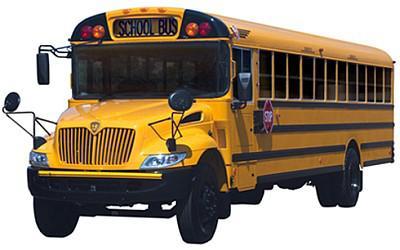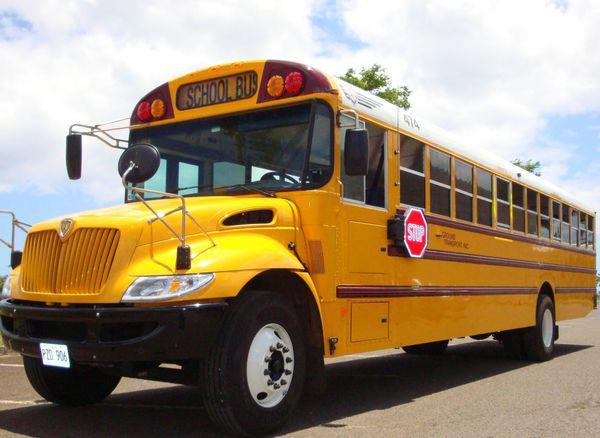The first image is the image on the left, the second image is the image on the right. Assess this claim about the two images: "At least one bus' doors are open.". Correct or not? Answer yes or no. No. The first image is the image on the left, the second image is the image on the right. For the images shown, is this caption "The two school buses are facing nearly opposite directions." true? Answer yes or no. No. 